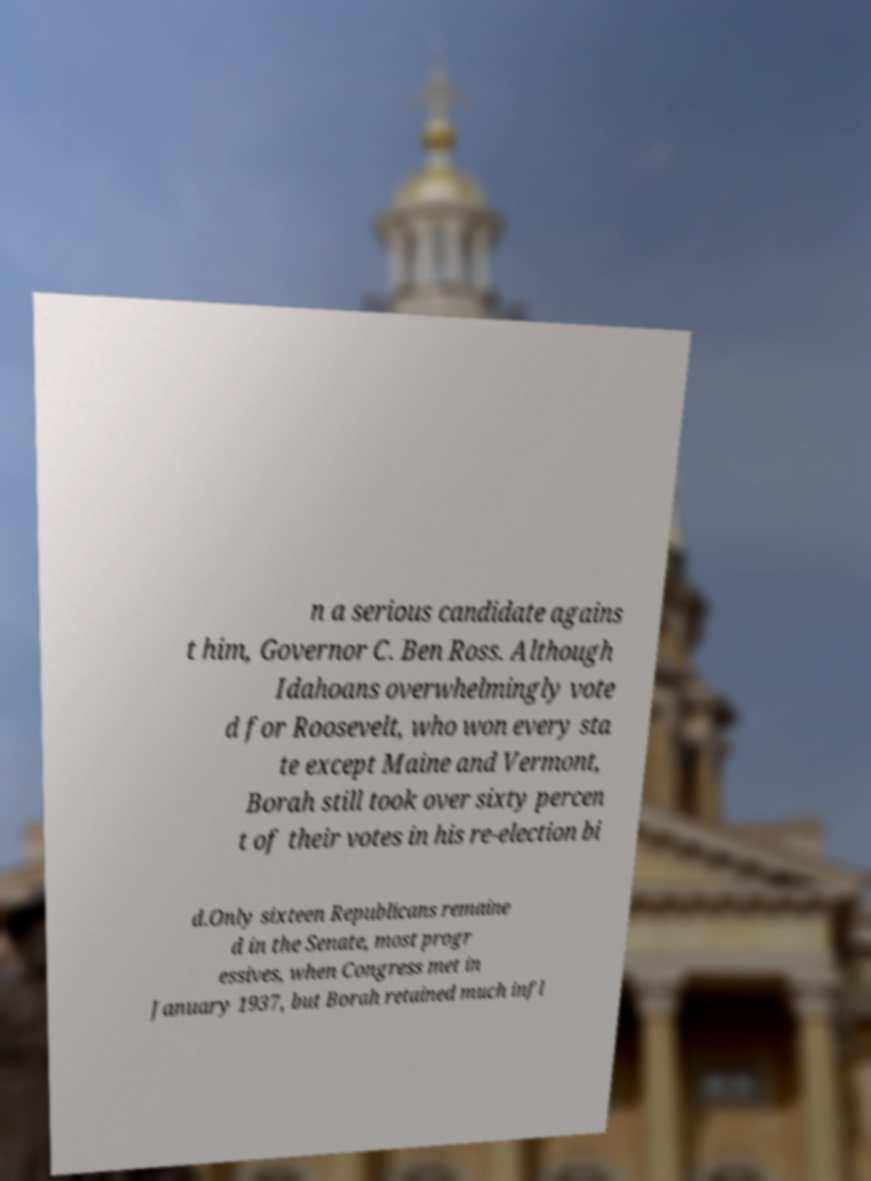Could you extract and type out the text from this image? n a serious candidate agains t him, Governor C. Ben Ross. Although Idahoans overwhelmingly vote d for Roosevelt, who won every sta te except Maine and Vermont, Borah still took over sixty percen t of their votes in his re-election bi d.Only sixteen Republicans remaine d in the Senate, most progr essives, when Congress met in January 1937, but Borah retained much infl 